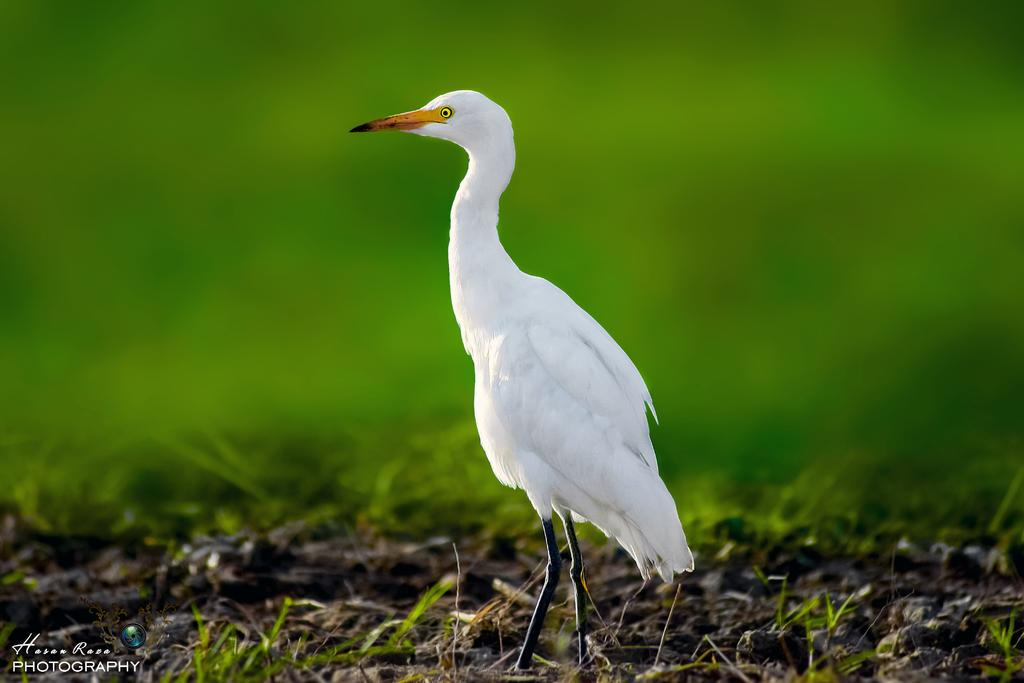What type of bird is in the image? There is a white color crane in the image. Where is the crane located? The crane is standing on the ground. What is on the ground where the crane is standing? There is grass on the ground. Can you describe the background of the image? The background of the image is blurred. What type of soda is the crane drinking in the image? There is no soda present in the image; the crane is standing on the ground with grass around it. 